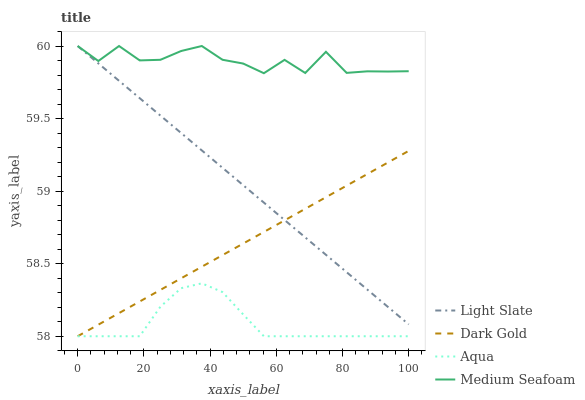Does Aqua have the minimum area under the curve?
Answer yes or no. Yes. Does Medium Seafoam have the maximum area under the curve?
Answer yes or no. Yes. Does Medium Seafoam have the minimum area under the curve?
Answer yes or no. No. Does Aqua have the maximum area under the curve?
Answer yes or no. No. Is Dark Gold the smoothest?
Answer yes or no. Yes. Is Medium Seafoam the roughest?
Answer yes or no. Yes. Is Aqua the smoothest?
Answer yes or no. No. Is Aqua the roughest?
Answer yes or no. No. Does Aqua have the lowest value?
Answer yes or no. Yes. Does Medium Seafoam have the lowest value?
Answer yes or no. No. Does Medium Seafoam have the highest value?
Answer yes or no. Yes. Does Aqua have the highest value?
Answer yes or no. No. Is Aqua less than Medium Seafoam?
Answer yes or no. Yes. Is Medium Seafoam greater than Aqua?
Answer yes or no. Yes. Does Medium Seafoam intersect Light Slate?
Answer yes or no. Yes. Is Medium Seafoam less than Light Slate?
Answer yes or no. No. Is Medium Seafoam greater than Light Slate?
Answer yes or no. No. Does Aqua intersect Medium Seafoam?
Answer yes or no. No. 